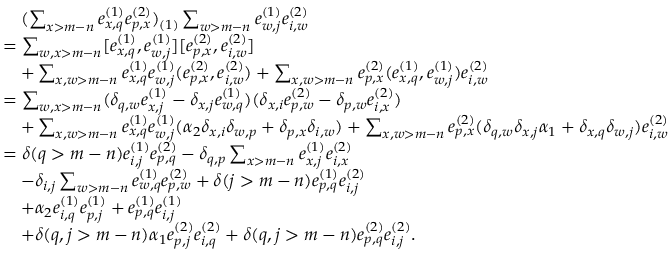<formula> <loc_0><loc_0><loc_500><loc_500>\begin{array} { r l } & { \quad ( \sum _ { x > m - n } e _ { x , q } ^ { ( 1 ) } e _ { p , x } ^ { ( 2 ) } ) _ { ( 1 ) } \sum _ { w > m - n } e _ { w , j } ^ { ( 1 ) } e _ { i , w } ^ { ( 2 ) } } \\ & { = \sum _ { w , x > m - n } [ e _ { x , q } ^ { ( 1 ) } , e _ { w , j } ^ { ( 1 ) } ] [ e _ { p , x } ^ { ( 2 ) } , e _ { i , w } ^ { ( 2 ) } ] } \\ & { \quad + \sum _ { x , w > m - n } e _ { x , q } ^ { ( 1 ) } e _ { w , j } ^ { ( 1 ) } ( e _ { p , x } ^ { ( 2 ) } , e _ { i , w } ^ { ( 2 ) } ) + \sum _ { x , w > m - n } e _ { p , x } ^ { ( 2 ) } ( e _ { x , q } ^ { ( 1 ) } , e _ { w , j } ^ { ( 1 ) } ) e _ { i , w } ^ { ( 2 ) } } \\ & { = \sum _ { w , x > m - n } ( \delta _ { q , w } e _ { x , j } ^ { ( 1 ) } - \delta _ { x , j } e _ { w , q } ^ { ( 1 ) } ) ( \delta _ { x , i } e _ { p , w } ^ { ( 2 ) } - \delta _ { p , w } e _ { i , x } ^ { ( 2 ) } ) } \\ & { \quad + \sum _ { x , w > m - n } e _ { x , q } ^ { ( 1 ) } e _ { w , j } ^ { ( 1 ) } ( \alpha _ { 2 } \delta _ { x , i } \delta _ { w , p } + \delta _ { p , x } \delta _ { i , w } ) + \sum _ { x , w > m - n } e _ { p , x } ^ { ( 2 ) } ( \delta _ { q , w } \delta _ { x , j } \alpha _ { 1 } + \delta _ { x , q } \delta _ { w , j } ) e _ { i , w } ^ { ( 2 ) } } \\ & { = \delta ( q > m - n ) e _ { i , j } ^ { ( 1 ) } e _ { p , q } ^ { ( 2 ) } - \delta _ { q , p } \sum _ { x > m - n } e _ { x , j } ^ { ( 1 ) } e _ { i , x } ^ { ( 2 ) } } \\ & { \quad - \delta _ { i , j } \sum _ { w > m - n } e _ { w , q } ^ { ( 1 ) } e _ { p , w } ^ { ( 2 ) } + \delta ( j > m - n ) e _ { p , q } ^ { ( 1 ) } e _ { i , j } ^ { ( 2 ) } } \\ & { \quad + \alpha _ { 2 } e _ { i , q } ^ { ( 1 ) } e _ { p , j } ^ { ( 1 ) } + e _ { p , q } ^ { ( 1 ) } e _ { i , j } ^ { ( 1 ) } } \\ & { \quad + \delta ( q , j > m - n ) \alpha _ { 1 } e _ { p , j } ^ { ( 2 ) } e _ { i , q } ^ { ( 2 ) } + \delta ( q , j > m - n ) e _ { p , q } ^ { ( 2 ) } e _ { i , j } ^ { ( 2 ) } . } \end{array}</formula> 